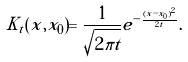Convert formula to latex. <formula><loc_0><loc_0><loc_500><loc_500>K _ { t } ( x , x _ { 0 } ) = \frac { 1 } { \sqrt { 2 \pi t } } e ^ { - \frac { ( x - x _ { 0 } ) ^ { 2 } } { 2 t } } .</formula> 